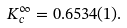Convert formula to latex. <formula><loc_0><loc_0><loc_500><loc_500>K _ { c } ^ { \infty } = 0 . 6 5 3 4 ( 1 ) .</formula> 